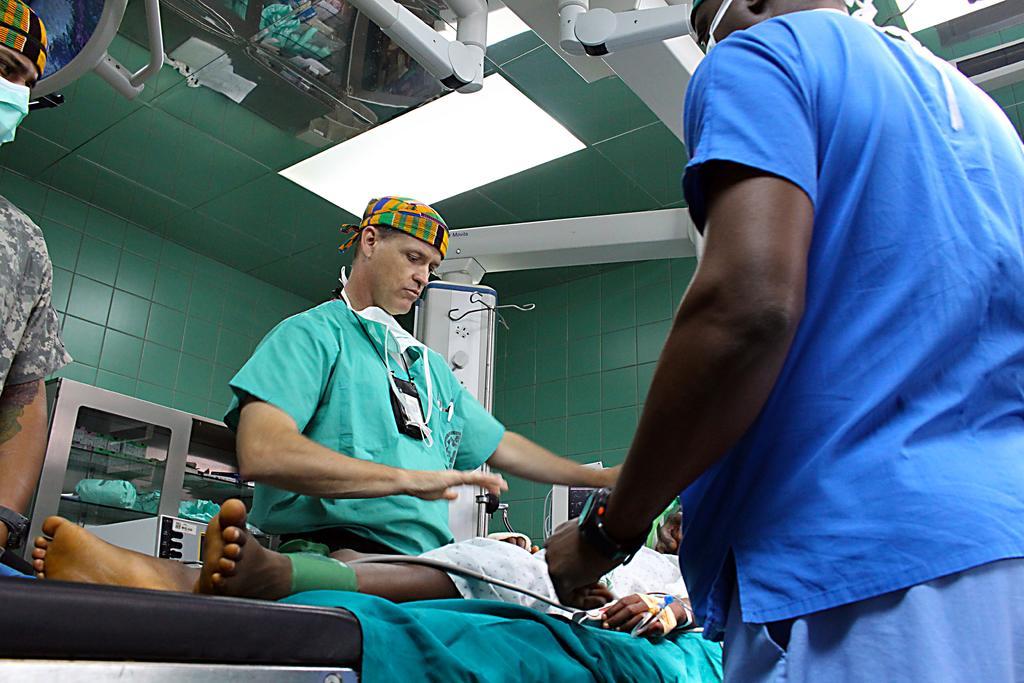Please provide a concise description of this image. In this picture there are three people standing and there is a person lying on the bed and we can see equipment. In the background of the image we can see wall. At the top of the image lights and ceiling. 